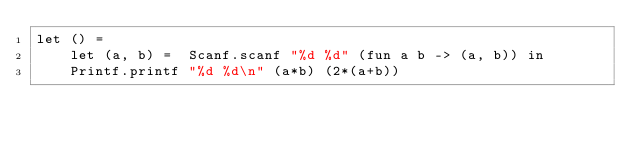Convert code to text. <code><loc_0><loc_0><loc_500><loc_500><_OCaml_>let () =
    let (a, b) =  Scanf.scanf "%d %d" (fun a b -> (a, b)) in
    Printf.printf "%d %d\n" (a*b) (2*(a+b))</code> 